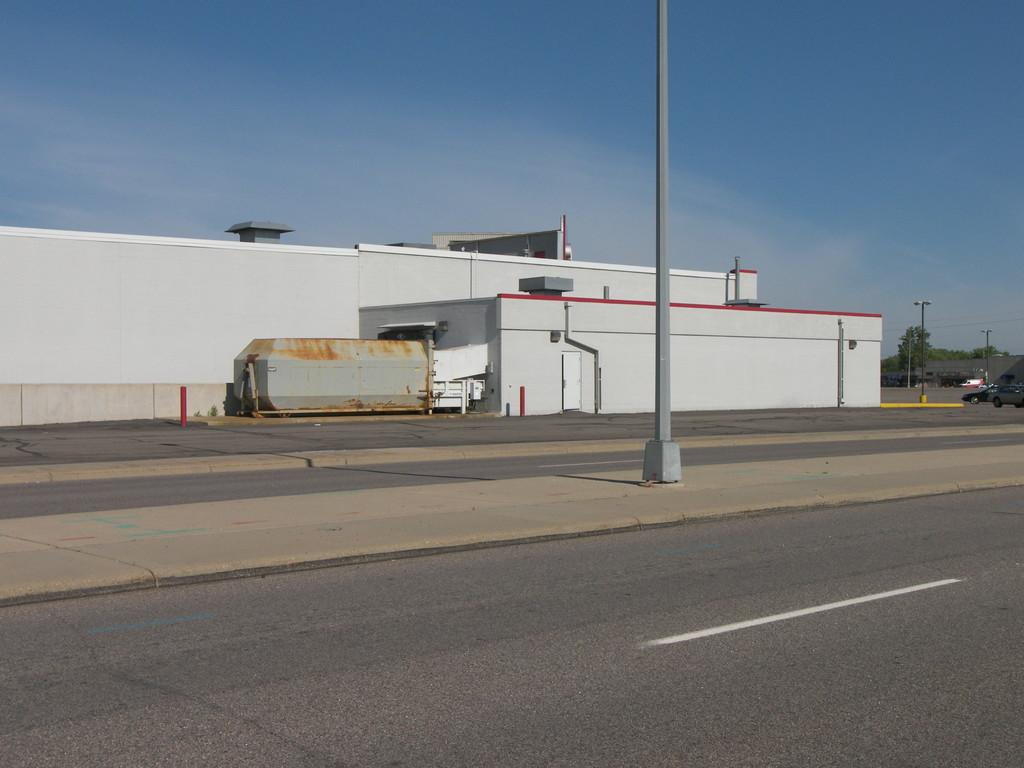What is the main feature of the image? There is a road in the image. What else can be seen in the image besides the road? There is a building, trees, two cars, and poles in the middle of the road. Can you describe the background of the image? The background of the image includes trees. How many cars are visible in the image? There are two cars in the background of the image. What type of cable can be seen hanging from the trees in the image? There is no cable hanging from the trees in the image. 